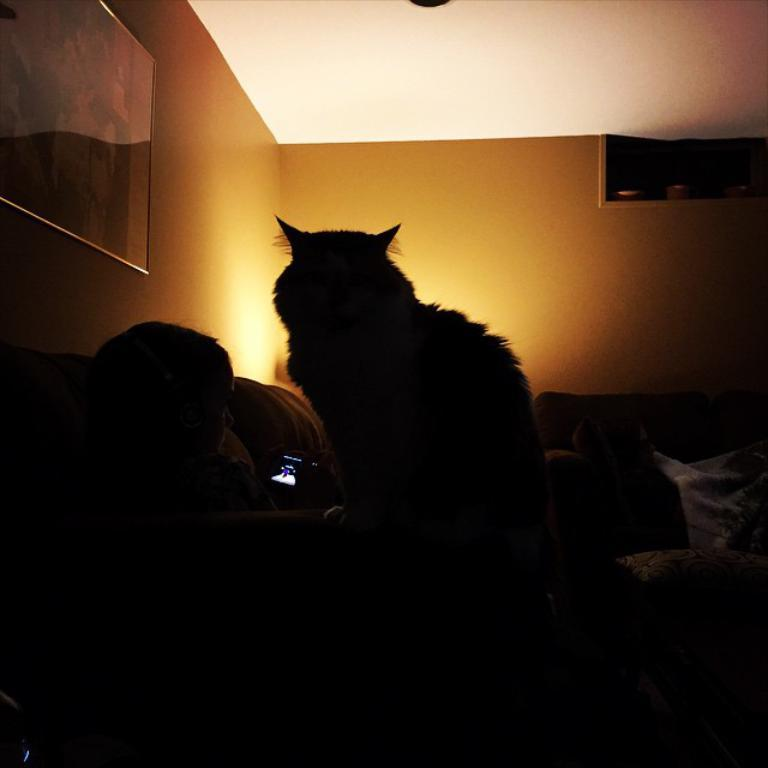What is hanging on the wall in the image? There is a photo frame on the wall in the image. What type of living creature can be seen in the image? There is an animal visible in the image. What piece of furniture is the person sitting on in the image? There is a person sitting on a sofa in the image. What type of degree is the person holding in the image? There is no person holding a degree in the image; the person is sitting on a sofa. How much lettuce is visible in the image? There is no lettuce present in the image. 